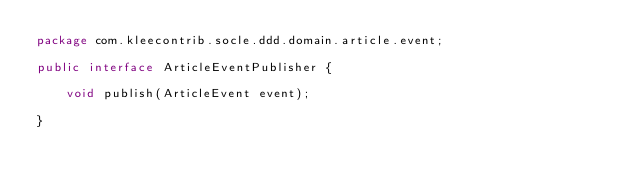<code> <loc_0><loc_0><loc_500><loc_500><_Java_>package com.kleecontrib.socle.ddd.domain.article.event;

public interface ArticleEventPublisher {

	void publish(ArticleEvent event);

}
</code> 